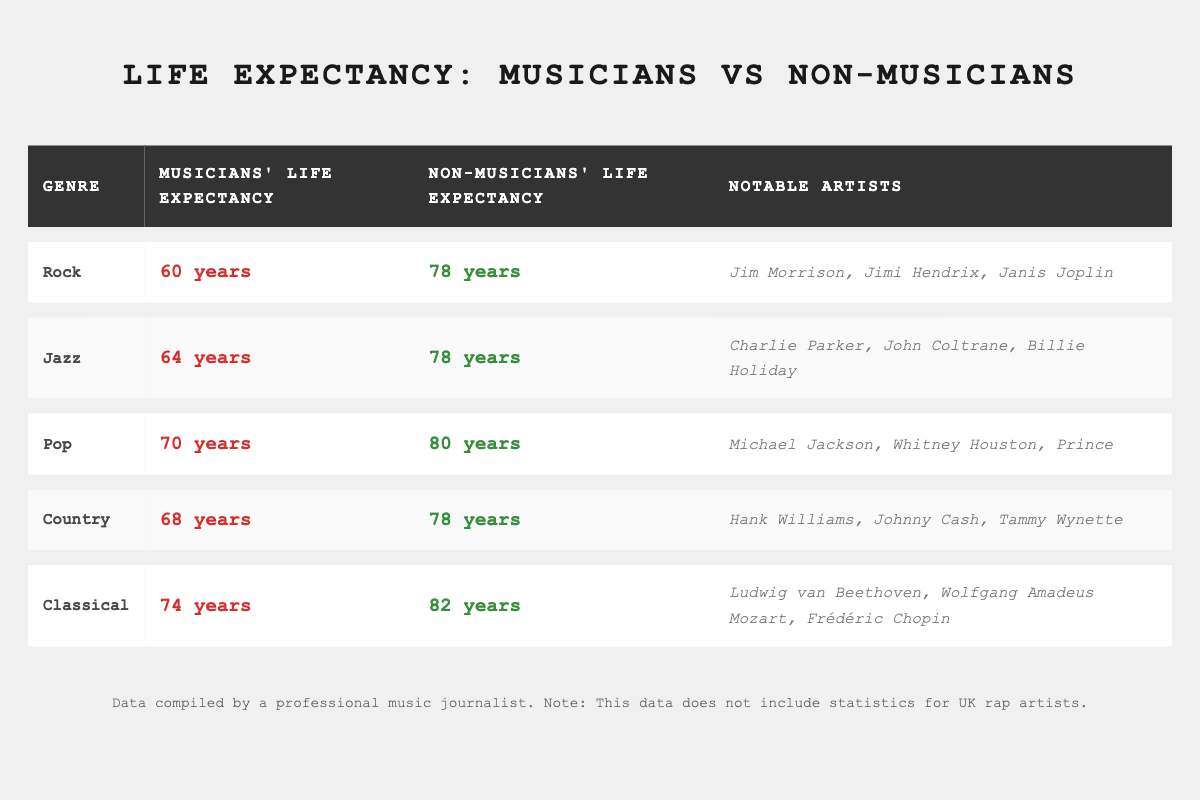What is the average life expectancy of musicians in the Rock genre? The table states that the average life expectancy of Rock musicians is 60 years.
Answer: 60 years How does the life expectancy of jazz musicians compare to that of non-musicians? Jazz musicians have an average life expectancy of 64 years, whereas non-musicians have an average life expectancy of 78 years. Thus, jazz musicians live 14 years shorter on average than non-musicians.
Answer: 14 years shorter Which genre has the highest average life expectancy for musicians? In the table, the Classical genre has the highest average life expectancy of 74 years for musicians.
Answer: 74 years Is it true that Country musicians have a higher life expectancy than Pop musicians? Country musicians average 68 years, whereas Pop musicians average 70 years. Therefore, the statement is false; Country musicians do not have a higher life expectancy than Pop musicians.
Answer: No What is the difference in life expectancy between Classical musicians and non-musicians? Classical musicians have an average life expectancy of 74 years, while non-musicians have an average of 82 years. The difference is 82 - 74 = 8 years, meaning Classical musicians live 8 years shorter on average than non-musicians.
Answer: 8 years What is the combined average life expectancy of all musicians listed in the table? The averages for musicians are 60 (Rock), 64 (Jazz), 70 (Pop), 68 (Country), and 74 (Classical). Adding these together gives 60 + 64 + 70 + 68 + 74 = 336. There are 5 genres, so the average is 336 / 5 = 67.2 years.
Answer: 67.2 years Do Jazz musicians or Classical musicians have a longer average life expectancy? Jazz musicians have an average life expectancy of 64 years, whereas Classical musicians average 74 years. Since 74 is greater than 64, Classical musicians have a longer average life expectancy.
Answer: Classical musicians How many genres listed have musicians whose life expectancy is below 70 years? The genres with musicians below 70 years are Rock (60 years) and Jazz (64 years). Thus, there are 2 genres where musicians have a life expectancy below 70 years.
Answer: 2 genres 